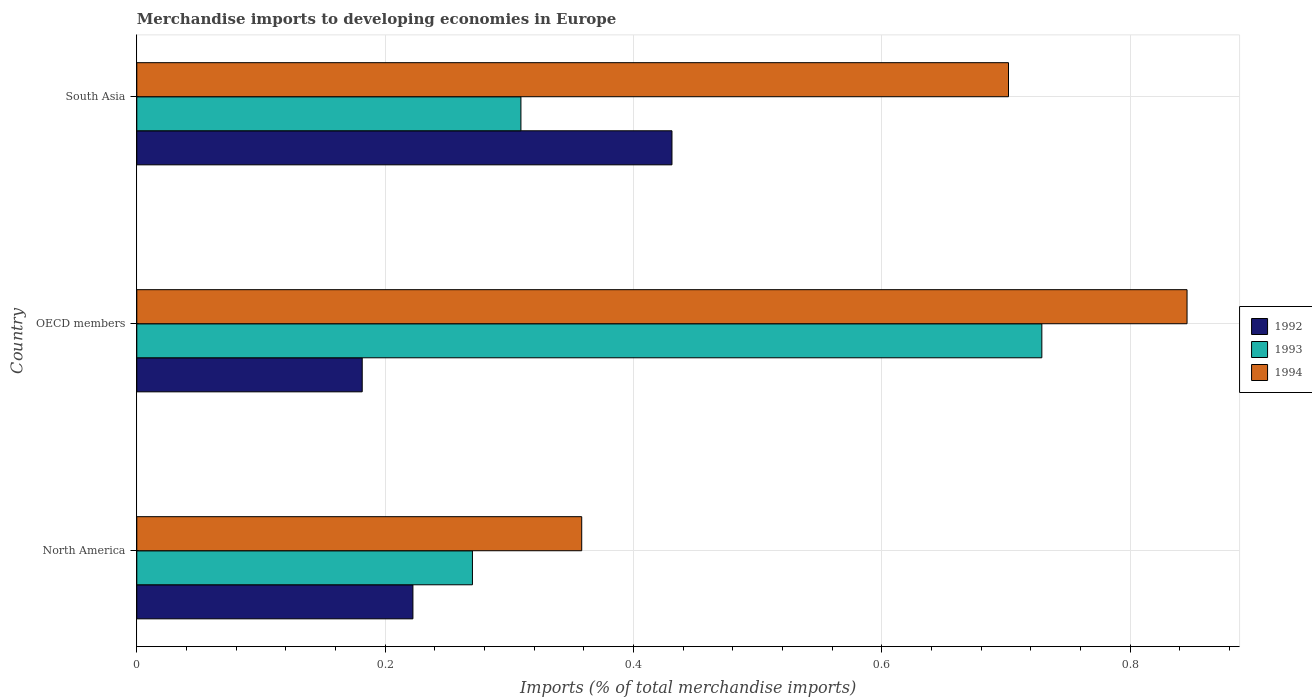How many different coloured bars are there?
Give a very brief answer. 3. Are the number of bars per tick equal to the number of legend labels?
Give a very brief answer. Yes. Are the number of bars on each tick of the Y-axis equal?
Provide a short and direct response. Yes. How many bars are there on the 2nd tick from the top?
Offer a terse response. 3. In how many cases, is the number of bars for a given country not equal to the number of legend labels?
Provide a succinct answer. 0. What is the percentage total merchandise imports in 1992 in North America?
Give a very brief answer. 0.22. Across all countries, what is the maximum percentage total merchandise imports in 1992?
Give a very brief answer. 0.43. Across all countries, what is the minimum percentage total merchandise imports in 1992?
Make the answer very short. 0.18. In which country was the percentage total merchandise imports in 1992 maximum?
Provide a short and direct response. South Asia. What is the total percentage total merchandise imports in 1994 in the graph?
Offer a very short reply. 1.91. What is the difference between the percentage total merchandise imports in 1992 in North America and that in OECD members?
Keep it short and to the point. 0.04. What is the difference between the percentage total merchandise imports in 1994 in North America and the percentage total merchandise imports in 1993 in OECD members?
Offer a very short reply. -0.37. What is the average percentage total merchandise imports in 1992 per country?
Provide a short and direct response. 0.28. What is the difference between the percentage total merchandise imports in 1994 and percentage total merchandise imports in 1993 in North America?
Keep it short and to the point. 0.09. In how many countries, is the percentage total merchandise imports in 1993 greater than 0.04 %?
Give a very brief answer. 3. What is the ratio of the percentage total merchandise imports in 1993 in OECD members to that in South Asia?
Ensure brevity in your answer.  2.36. Is the percentage total merchandise imports in 1992 in OECD members less than that in South Asia?
Make the answer very short. Yes. What is the difference between the highest and the second highest percentage total merchandise imports in 1994?
Provide a short and direct response. 0.14. What is the difference between the highest and the lowest percentage total merchandise imports in 1992?
Offer a terse response. 0.25. Is the sum of the percentage total merchandise imports in 1993 in North America and South Asia greater than the maximum percentage total merchandise imports in 1992 across all countries?
Ensure brevity in your answer.  Yes. What does the 2nd bar from the top in South Asia represents?
Make the answer very short. 1993. What does the 1st bar from the bottom in North America represents?
Provide a short and direct response. 1992. How many bars are there?
Offer a terse response. 9. What is the difference between two consecutive major ticks on the X-axis?
Offer a very short reply. 0.2. Are the values on the major ticks of X-axis written in scientific E-notation?
Give a very brief answer. No. Where does the legend appear in the graph?
Offer a terse response. Center right. How many legend labels are there?
Your answer should be compact. 3. What is the title of the graph?
Provide a short and direct response. Merchandise imports to developing economies in Europe. Does "1960" appear as one of the legend labels in the graph?
Your answer should be very brief. No. What is the label or title of the X-axis?
Your answer should be very brief. Imports (% of total merchandise imports). What is the Imports (% of total merchandise imports) of 1992 in North America?
Give a very brief answer. 0.22. What is the Imports (% of total merchandise imports) of 1993 in North America?
Offer a terse response. 0.27. What is the Imports (% of total merchandise imports) in 1994 in North America?
Make the answer very short. 0.36. What is the Imports (% of total merchandise imports) in 1992 in OECD members?
Offer a very short reply. 0.18. What is the Imports (% of total merchandise imports) of 1993 in OECD members?
Give a very brief answer. 0.73. What is the Imports (% of total merchandise imports) in 1994 in OECD members?
Keep it short and to the point. 0.85. What is the Imports (% of total merchandise imports) of 1992 in South Asia?
Make the answer very short. 0.43. What is the Imports (% of total merchandise imports) of 1993 in South Asia?
Provide a succinct answer. 0.31. What is the Imports (% of total merchandise imports) of 1994 in South Asia?
Your answer should be very brief. 0.7. Across all countries, what is the maximum Imports (% of total merchandise imports) in 1992?
Make the answer very short. 0.43. Across all countries, what is the maximum Imports (% of total merchandise imports) of 1993?
Offer a terse response. 0.73. Across all countries, what is the maximum Imports (% of total merchandise imports) in 1994?
Keep it short and to the point. 0.85. Across all countries, what is the minimum Imports (% of total merchandise imports) of 1992?
Your answer should be compact. 0.18. Across all countries, what is the minimum Imports (% of total merchandise imports) in 1993?
Ensure brevity in your answer.  0.27. Across all countries, what is the minimum Imports (% of total merchandise imports) of 1994?
Offer a very short reply. 0.36. What is the total Imports (% of total merchandise imports) in 1992 in the graph?
Ensure brevity in your answer.  0.83. What is the total Imports (% of total merchandise imports) of 1993 in the graph?
Keep it short and to the point. 1.31. What is the total Imports (% of total merchandise imports) of 1994 in the graph?
Offer a very short reply. 1.91. What is the difference between the Imports (% of total merchandise imports) of 1992 in North America and that in OECD members?
Make the answer very short. 0.04. What is the difference between the Imports (% of total merchandise imports) in 1993 in North America and that in OECD members?
Offer a terse response. -0.46. What is the difference between the Imports (% of total merchandise imports) of 1994 in North America and that in OECD members?
Your response must be concise. -0.49. What is the difference between the Imports (% of total merchandise imports) of 1992 in North America and that in South Asia?
Your answer should be compact. -0.21. What is the difference between the Imports (% of total merchandise imports) of 1993 in North America and that in South Asia?
Your response must be concise. -0.04. What is the difference between the Imports (% of total merchandise imports) in 1994 in North America and that in South Asia?
Your answer should be very brief. -0.34. What is the difference between the Imports (% of total merchandise imports) in 1992 in OECD members and that in South Asia?
Provide a short and direct response. -0.25. What is the difference between the Imports (% of total merchandise imports) in 1993 in OECD members and that in South Asia?
Ensure brevity in your answer.  0.42. What is the difference between the Imports (% of total merchandise imports) of 1994 in OECD members and that in South Asia?
Ensure brevity in your answer.  0.14. What is the difference between the Imports (% of total merchandise imports) in 1992 in North America and the Imports (% of total merchandise imports) in 1993 in OECD members?
Make the answer very short. -0.51. What is the difference between the Imports (% of total merchandise imports) of 1992 in North America and the Imports (% of total merchandise imports) of 1994 in OECD members?
Provide a short and direct response. -0.62. What is the difference between the Imports (% of total merchandise imports) of 1993 in North America and the Imports (% of total merchandise imports) of 1994 in OECD members?
Offer a very short reply. -0.58. What is the difference between the Imports (% of total merchandise imports) of 1992 in North America and the Imports (% of total merchandise imports) of 1993 in South Asia?
Keep it short and to the point. -0.09. What is the difference between the Imports (% of total merchandise imports) in 1992 in North America and the Imports (% of total merchandise imports) in 1994 in South Asia?
Ensure brevity in your answer.  -0.48. What is the difference between the Imports (% of total merchandise imports) of 1993 in North America and the Imports (% of total merchandise imports) of 1994 in South Asia?
Offer a terse response. -0.43. What is the difference between the Imports (% of total merchandise imports) in 1992 in OECD members and the Imports (% of total merchandise imports) in 1993 in South Asia?
Offer a terse response. -0.13. What is the difference between the Imports (% of total merchandise imports) in 1992 in OECD members and the Imports (% of total merchandise imports) in 1994 in South Asia?
Give a very brief answer. -0.52. What is the difference between the Imports (% of total merchandise imports) of 1993 in OECD members and the Imports (% of total merchandise imports) of 1994 in South Asia?
Ensure brevity in your answer.  0.03. What is the average Imports (% of total merchandise imports) in 1992 per country?
Your answer should be very brief. 0.28. What is the average Imports (% of total merchandise imports) in 1993 per country?
Keep it short and to the point. 0.44. What is the average Imports (% of total merchandise imports) of 1994 per country?
Offer a very short reply. 0.64. What is the difference between the Imports (% of total merchandise imports) in 1992 and Imports (% of total merchandise imports) in 1993 in North America?
Give a very brief answer. -0.05. What is the difference between the Imports (% of total merchandise imports) in 1992 and Imports (% of total merchandise imports) in 1994 in North America?
Provide a succinct answer. -0.14. What is the difference between the Imports (% of total merchandise imports) in 1993 and Imports (% of total merchandise imports) in 1994 in North America?
Keep it short and to the point. -0.09. What is the difference between the Imports (% of total merchandise imports) of 1992 and Imports (% of total merchandise imports) of 1993 in OECD members?
Ensure brevity in your answer.  -0.55. What is the difference between the Imports (% of total merchandise imports) of 1992 and Imports (% of total merchandise imports) of 1994 in OECD members?
Ensure brevity in your answer.  -0.66. What is the difference between the Imports (% of total merchandise imports) in 1993 and Imports (% of total merchandise imports) in 1994 in OECD members?
Provide a short and direct response. -0.12. What is the difference between the Imports (% of total merchandise imports) of 1992 and Imports (% of total merchandise imports) of 1993 in South Asia?
Your answer should be compact. 0.12. What is the difference between the Imports (% of total merchandise imports) in 1992 and Imports (% of total merchandise imports) in 1994 in South Asia?
Offer a terse response. -0.27. What is the difference between the Imports (% of total merchandise imports) in 1993 and Imports (% of total merchandise imports) in 1994 in South Asia?
Keep it short and to the point. -0.39. What is the ratio of the Imports (% of total merchandise imports) of 1992 in North America to that in OECD members?
Make the answer very short. 1.23. What is the ratio of the Imports (% of total merchandise imports) in 1993 in North America to that in OECD members?
Ensure brevity in your answer.  0.37. What is the ratio of the Imports (% of total merchandise imports) of 1994 in North America to that in OECD members?
Give a very brief answer. 0.42. What is the ratio of the Imports (% of total merchandise imports) in 1992 in North America to that in South Asia?
Your response must be concise. 0.52. What is the ratio of the Imports (% of total merchandise imports) of 1993 in North America to that in South Asia?
Keep it short and to the point. 0.87. What is the ratio of the Imports (% of total merchandise imports) of 1994 in North America to that in South Asia?
Give a very brief answer. 0.51. What is the ratio of the Imports (% of total merchandise imports) in 1992 in OECD members to that in South Asia?
Offer a very short reply. 0.42. What is the ratio of the Imports (% of total merchandise imports) in 1993 in OECD members to that in South Asia?
Ensure brevity in your answer.  2.36. What is the ratio of the Imports (% of total merchandise imports) of 1994 in OECD members to that in South Asia?
Provide a succinct answer. 1.2. What is the difference between the highest and the second highest Imports (% of total merchandise imports) of 1992?
Your answer should be compact. 0.21. What is the difference between the highest and the second highest Imports (% of total merchandise imports) of 1993?
Provide a succinct answer. 0.42. What is the difference between the highest and the second highest Imports (% of total merchandise imports) of 1994?
Provide a succinct answer. 0.14. What is the difference between the highest and the lowest Imports (% of total merchandise imports) of 1992?
Ensure brevity in your answer.  0.25. What is the difference between the highest and the lowest Imports (% of total merchandise imports) in 1993?
Your response must be concise. 0.46. What is the difference between the highest and the lowest Imports (% of total merchandise imports) in 1994?
Make the answer very short. 0.49. 